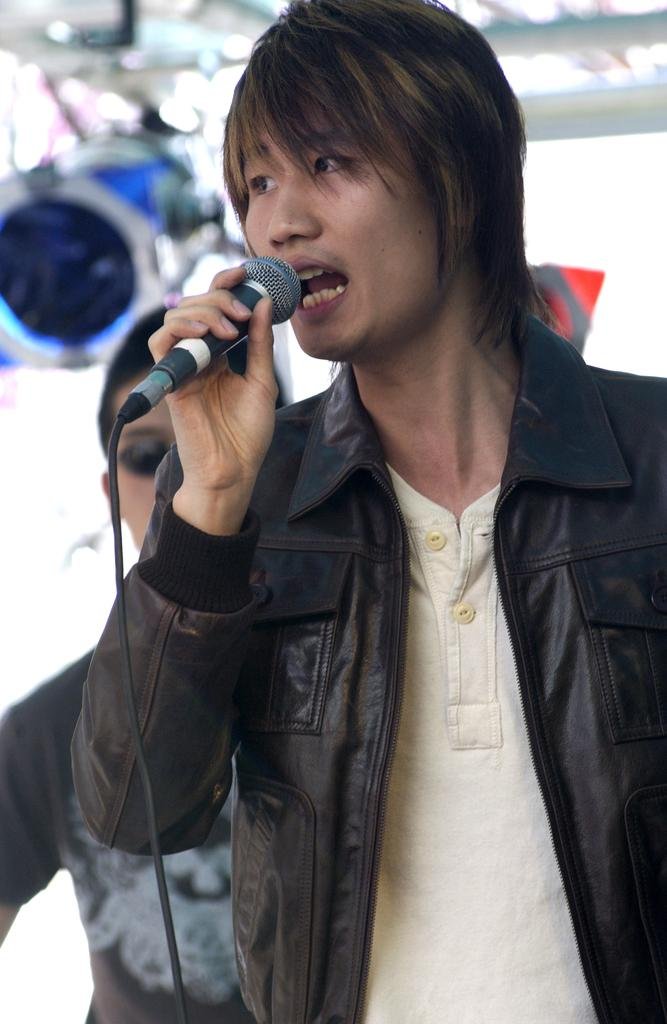What is the man in the image holding? The man is holding a microphone. What type of clothing is the man wearing on his upper body? The man is wearing a black jacket and a cream-colored t-shirt. What type of quartz can be seen in the image? There is no quartz present in the image. What is the aftermath of the event in the image? There is no event or aftermath mentioned in the provided facts about the image. 